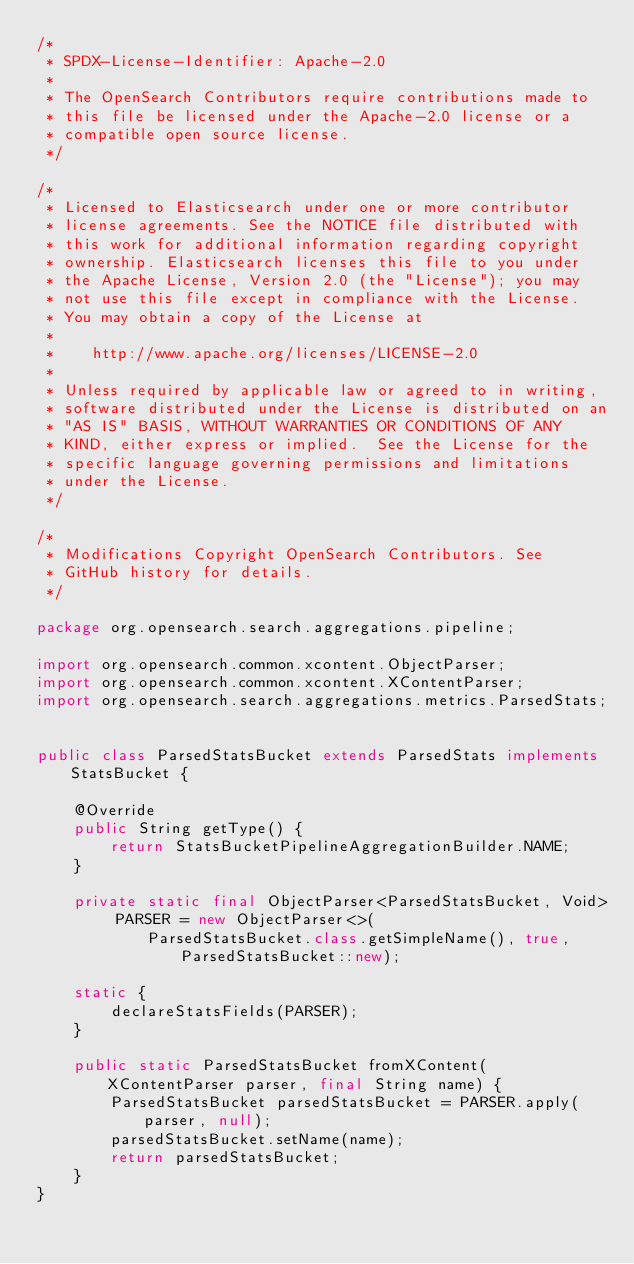Convert code to text. <code><loc_0><loc_0><loc_500><loc_500><_Java_>/*
 * SPDX-License-Identifier: Apache-2.0
 *
 * The OpenSearch Contributors require contributions made to
 * this file be licensed under the Apache-2.0 license or a
 * compatible open source license.
 */

/*
 * Licensed to Elasticsearch under one or more contributor
 * license agreements. See the NOTICE file distributed with
 * this work for additional information regarding copyright
 * ownership. Elasticsearch licenses this file to you under
 * the Apache License, Version 2.0 (the "License"); you may
 * not use this file except in compliance with the License.
 * You may obtain a copy of the License at
 *
 *    http://www.apache.org/licenses/LICENSE-2.0
 *
 * Unless required by applicable law or agreed to in writing,
 * software distributed under the License is distributed on an
 * "AS IS" BASIS, WITHOUT WARRANTIES OR CONDITIONS OF ANY
 * KIND, either express or implied.  See the License for the
 * specific language governing permissions and limitations
 * under the License.
 */

/*
 * Modifications Copyright OpenSearch Contributors. See
 * GitHub history for details.
 */

package org.opensearch.search.aggregations.pipeline;

import org.opensearch.common.xcontent.ObjectParser;
import org.opensearch.common.xcontent.XContentParser;
import org.opensearch.search.aggregations.metrics.ParsedStats;


public class ParsedStatsBucket extends ParsedStats implements StatsBucket {

    @Override
    public String getType() {
        return StatsBucketPipelineAggregationBuilder.NAME;
    }

    private static final ObjectParser<ParsedStatsBucket, Void> PARSER = new ObjectParser<>(
            ParsedStatsBucket.class.getSimpleName(), true, ParsedStatsBucket::new);

    static {
        declareStatsFields(PARSER);
    }

    public static ParsedStatsBucket fromXContent(XContentParser parser, final String name) {
        ParsedStatsBucket parsedStatsBucket = PARSER.apply(parser, null);
        parsedStatsBucket.setName(name);
        return parsedStatsBucket;
    }
}
</code> 